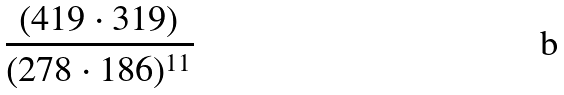Convert formula to latex. <formula><loc_0><loc_0><loc_500><loc_500>\frac { ( 4 1 9 \cdot 3 1 9 ) } { ( 2 7 8 \cdot 1 8 6 ) ^ { 1 1 } }</formula> 